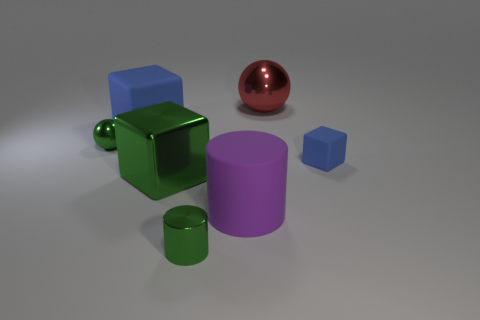Add 2 rubber cylinders. How many objects exist? 9 Subtract all spheres. How many objects are left? 5 Subtract all rubber things. Subtract all small rubber things. How many objects are left? 3 Add 1 small blocks. How many small blocks are left? 2 Add 1 small gray spheres. How many small gray spheres exist? 1 Subtract 0 blue spheres. How many objects are left? 7 